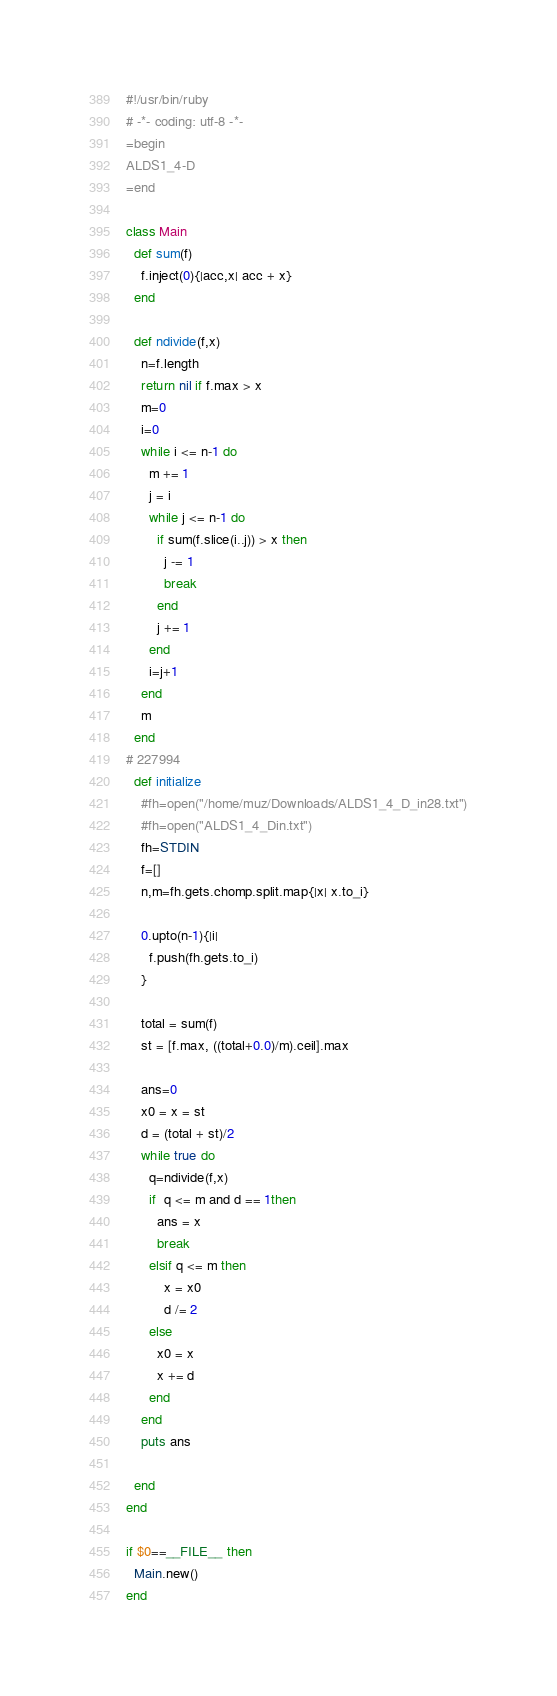Convert code to text. <code><loc_0><loc_0><loc_500><loc_500><_Ruby_>#!/usr/bin/ruby
# -*- coding: utf-8 -*-
=begin
ALDS1_4-D
=end

class Main
  def sum(f)
    f.inject(0){|acc,x| acc + x}
  end

  def ndivide(f,x)
    n=f.length
    return nil if f.max > x
    m=0
    i=0
    while i <= n-1 do
      m += 1
      j = i
      while j <= n-1 do
        if sum(f.slice(i..j)) > x then
          j -= 1
          break
        end
        j += 1
      end
      i=j+1
    end
    m
  end
# 227994
  def initialize
    #fh=open("/home/muz/Downloads/ALDS1_4_D_in28.txt")
    #fh=open("ALDS1_4_Din.txt")
    fh=STDIN
    f=[]
    n,m=fh.gets.chomp.split.map{|x| x.to_i}

    0.upto(n-1){|i|
      f.push(fh.gets.to_i)
    }

    total = sum(f)
    st = [f.max, ((total+0.0)/m).ceil].max

    ans=0
    x0 = x = st
    d = (total + st)/2
    while true do
      q=ndivide(f,x)
      if  q <= m and d == 1then
        ans = x
        break
      elsif q <= m then 
          x = x0
          d /= 2
      else
        x0 = x
        x += d
      end
    end
    puts ans

  end
end

if $0==__FILE__ then
  Main.new()
end</code> 